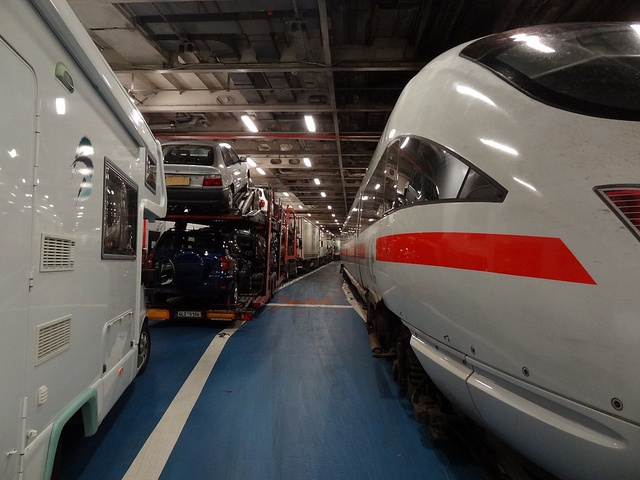Describe the objects in this image and their specific colors. I can see train in gray, black, and darkgray tones, truck in darkgray, gray, and black tones, car in gray, black, maroon, and darkgray tones, car in gray, black, and darkgray tones, and truck in gray, darkgray, and black tones in this image. 